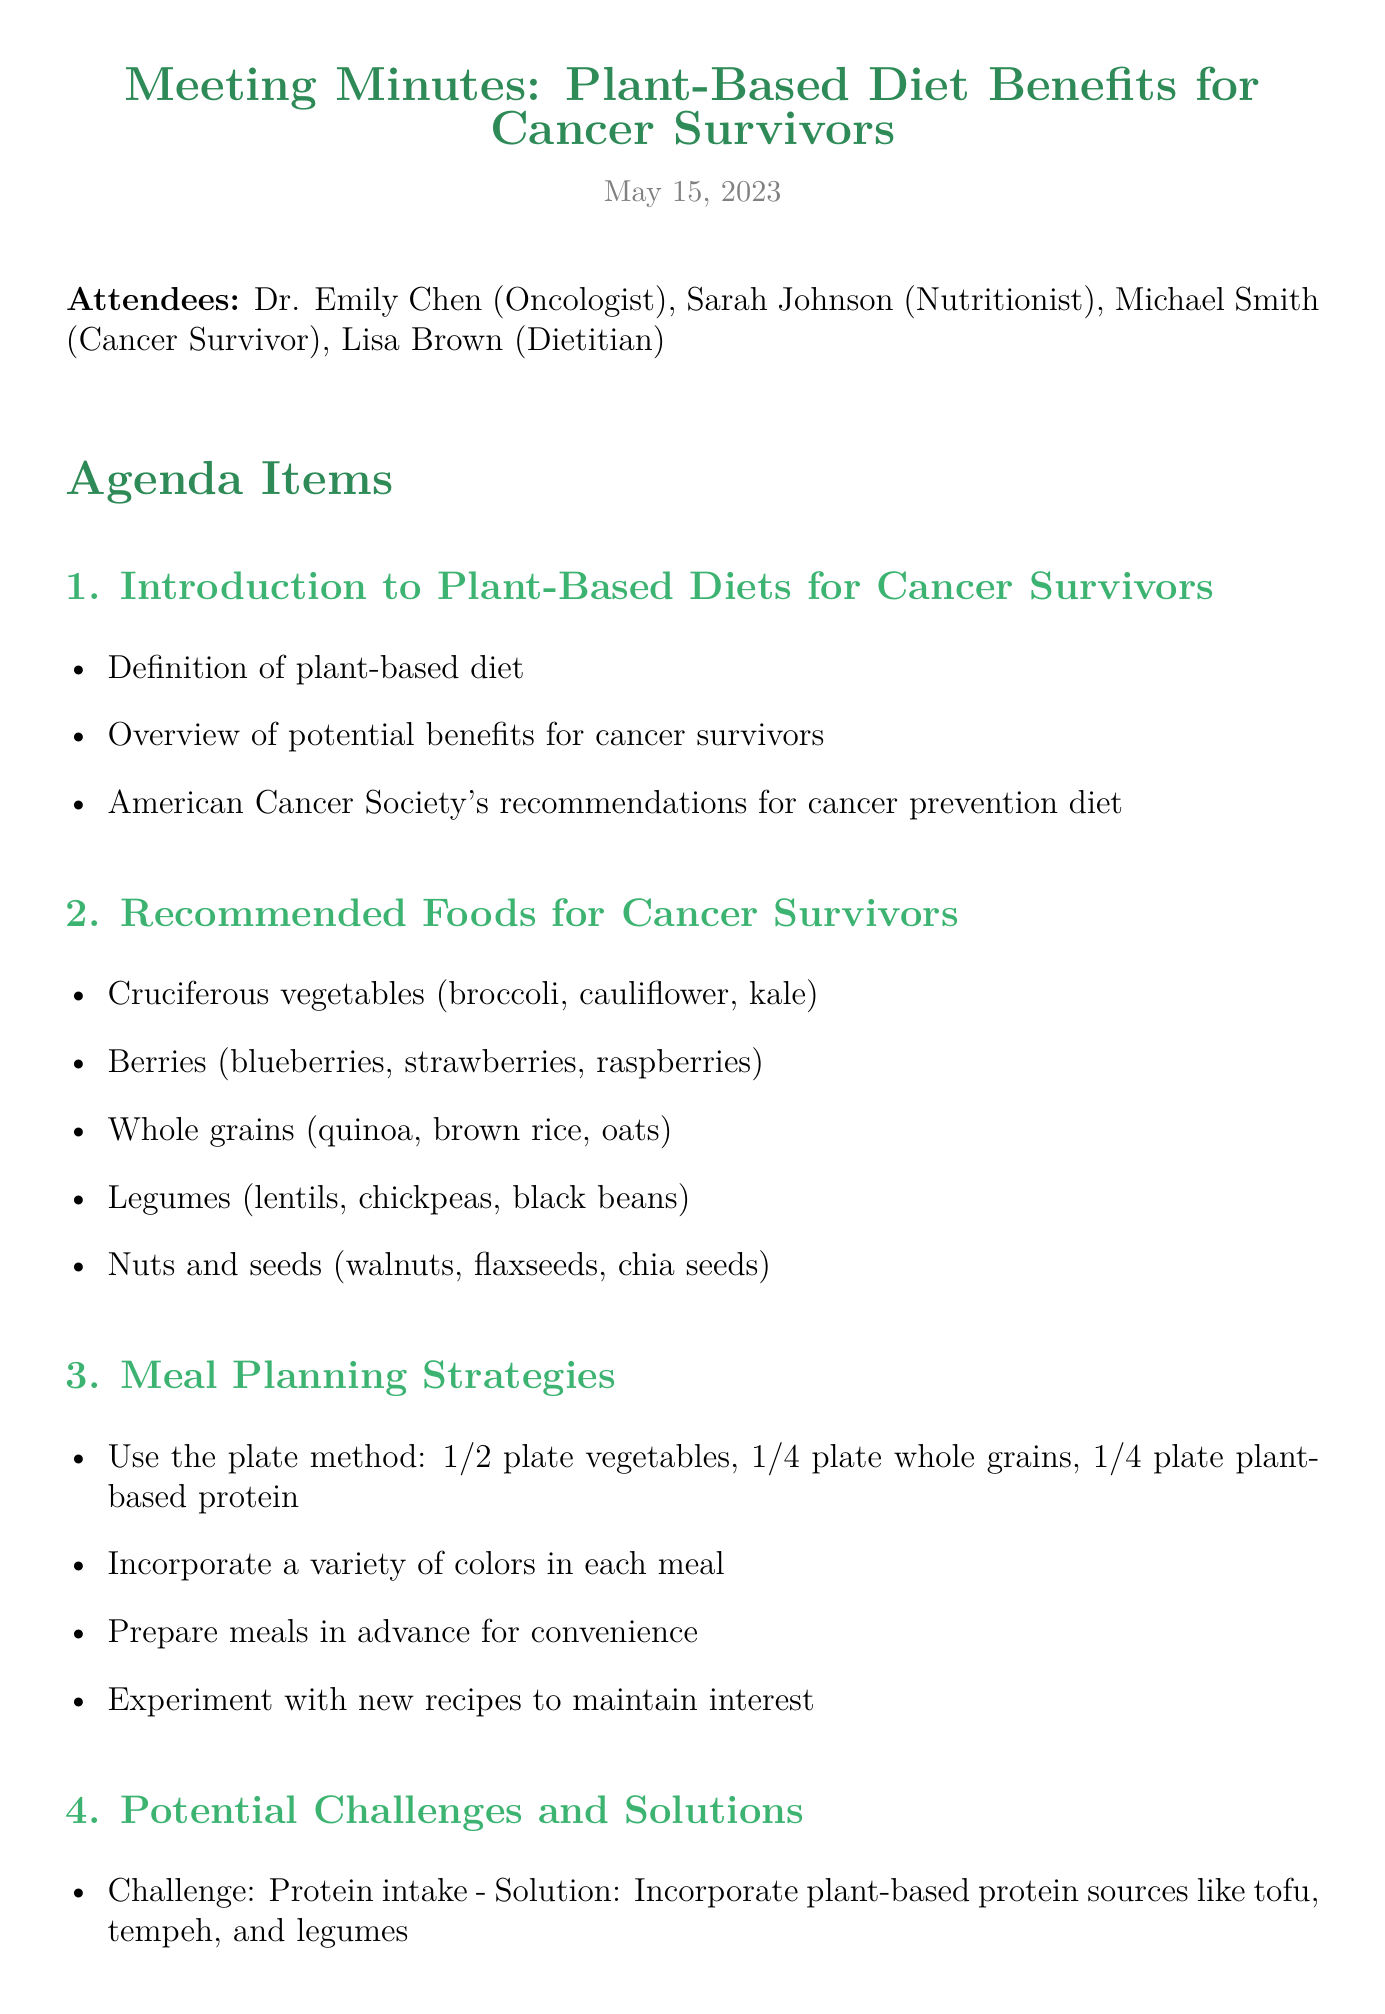What is the meeting date? The meeting date is listed at the beginning of the document under the meeting title and subtitle.
Answer: May 15, 2023 Who is the nutritionist at the meeting? The nutritionist is mentioned among the attendees at the beginning of the document.
Answer: Sarah Johnson What type of vegetables are recommended for cancer survivors? This information is summarized in the section regarding recommended foods for cancer survivors.
Answer: Cruciferous vegetables What is one meal planning strategy suggested? The meal planning strategies are detailed in their respective section.
Answer: Use the plate method What is a challenge related to protein intake? This challenge is highlighted in the section discussing potential challenges and solutions.
Answer: Protein intake Which organization provides resources for cancer research? This information is provided in the section about resources for further information.
Answer: American Institute for Cancer Research How many attendees were present at the meeting? The number of attendees can be inferred from the list at the beginning of the document.
Answer: Four What should be included in half of the plate according to the meal planning strategy? This is specified in the meal planning strategies section discussing portion sizes.
Answer: Vegetables What action item involves a follow-up with a nutritionist? This action item is listed at the end of the document in the action items section.
Answer: Schedule follow-up appointment with nutritionist for personalized meal plan 